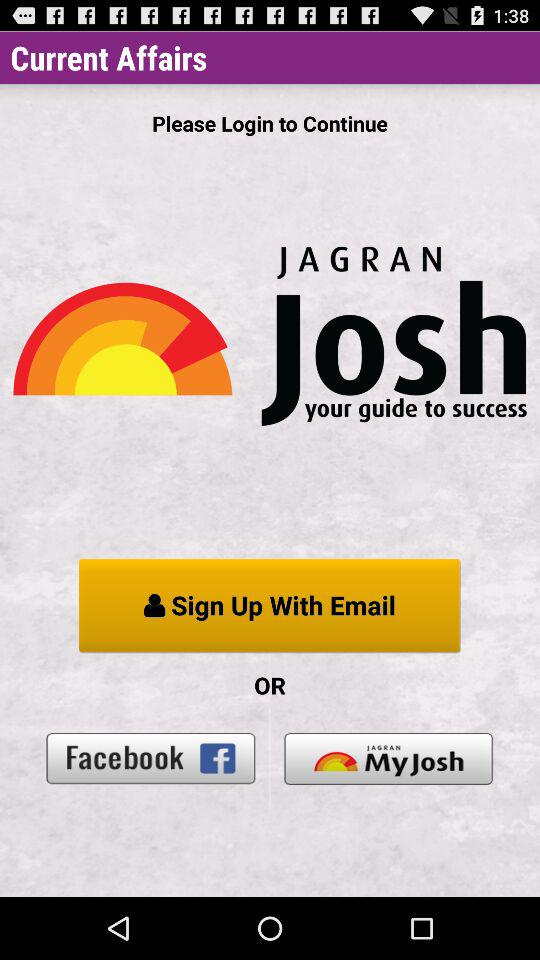Through which applications can we sign in? You can sign in through "Facebook" and "Jagran Josh". 